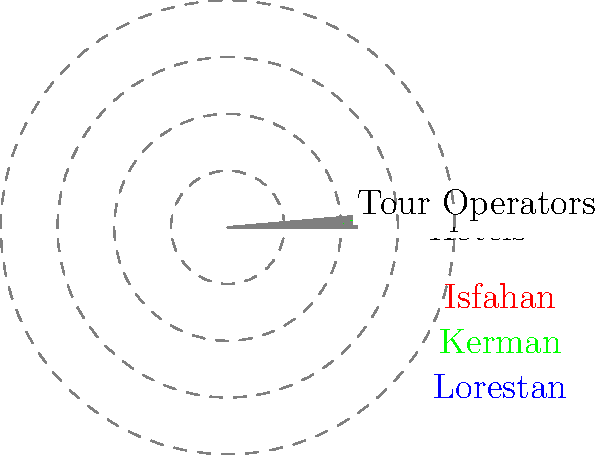Based on the radar chart showing tourism infrastructure for three Iranian provinces, which clustering technique would be most appropriate to group these provinces, and what insights can be drawn about their tourism development? To answer this question, let's analyze the radar chart and consider appropriate clustering techniques:

1. Data representation: The radar chart shows five tourism infrastructure indicators (Hotels, Restaurants, Transportation, Attractions, and Tour Operators) for three Iranian provinces (Isfahan, Kerman, and Lorestan).

2. Visual analysis:
   - Isfahan (red) has high values across all indicators, especially in Hotels, Transportation, and Attractions.
   - Kerman (green) shows moderate values, with Transportation being its strongest feature.
   - Lorestan (blue) has low values across all indicators.

3. Clustering technique selection:
   - Given the small number of provinces (3) and the multidimensional nature of the data (5 indicators), hierarchical clustering would be most appropriate.
   - K-means clustering is less suitable due to the small sample size.

4. Hierarchical clustering process:
   - Calculate the Euclidean distance between provinces based on their indicator values.
   - Group the closest provinces together, forming clusters.
   - In this case, Kerman and Lorestan would likely form a cluster first, with Isfahan remaining separate due to its higher values.

5. Insights on tourism development:
   - Isfahan appears to have the most developed tourism infrastructure, indicating a mature tourism sector.
   - Kerman shows moderate development, suggesting potential for growth.
   - Lorestan has the least developed infrastructure, indicating a need for significant investment in tourism facilities.

6. Policy implications:
   - Targeted investments could be made to improve specific indicators in each province.
   - Knowledge transfer from Isfahan to other provinces could help in developing their tourism sectors.
   - A regional tourism development strategy could be formulated based on these clusters.
Answer: Hierarchical clustering; Isfahan is most developed, Kerman moderate, Lorestan least developed in tourism infrastructure. 